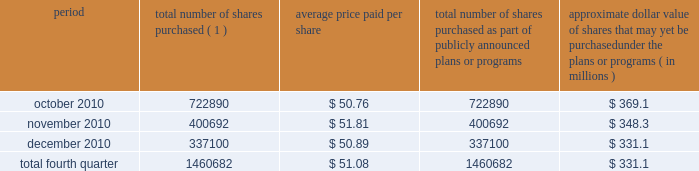Issuer purchases of equity securities during the three months ended december 31 , 2010 , we repurchased 1460682 shares of our common stock for an aggregate of $ 74.6 million , including commissions and fees , pursuant to our publicly announced stock repurchase program , as follows : period total number of shares purchased ( 1 ) average price paid per share total number of shares purchased as part of publicly announced plans or programs approximate dollar value of shares that may yet be purchased under the plans or programs ( in millions ) .
( 1 ) repurchases made pursuant to the $ 1.5 billion stock repurchase program approved by our board of directors in february 2008 ( the 201cbuyback 201d ) .
Under this program , our management is authorized to purchase shares from time to time through open market purchases or privately negotiated transactions at prevailing prices as permitted by securities laws and other legal requirements , and subject to market conditions and other factors .
To facilitate repurchases , we make purchases pursuant to trading plans under rule 10b5-1 of the exchange act , which allows us to repurchase shares during periods when we otherwise might be prevented from doing so under insider trading laws or because of self-imposed trading blackout periods .
This program may be discontinued at any time .
Subsequent to december 31 , 2010 , we repurchased 1122481 shares of our common stock for an aggregate of $ 58.0 million , including commissions and fees , pursuant to the buyback .
As of february 11 , 2011 , we had repurchased a total of 30.9 million shares of our common stock for an aggregate of $ 1.2 billion , including commissions and fees pursuant to the buyback .
We expect to continue to manage the pacing of the remaining $ 273.1 million under the buyback in response to general market conditions and other relevant factors. .
What was the percent of the total number of shares purchased in fourth quarter of 2010 in october? 
Computations: (722890 / 1460682)
Answer: 0.4949. 